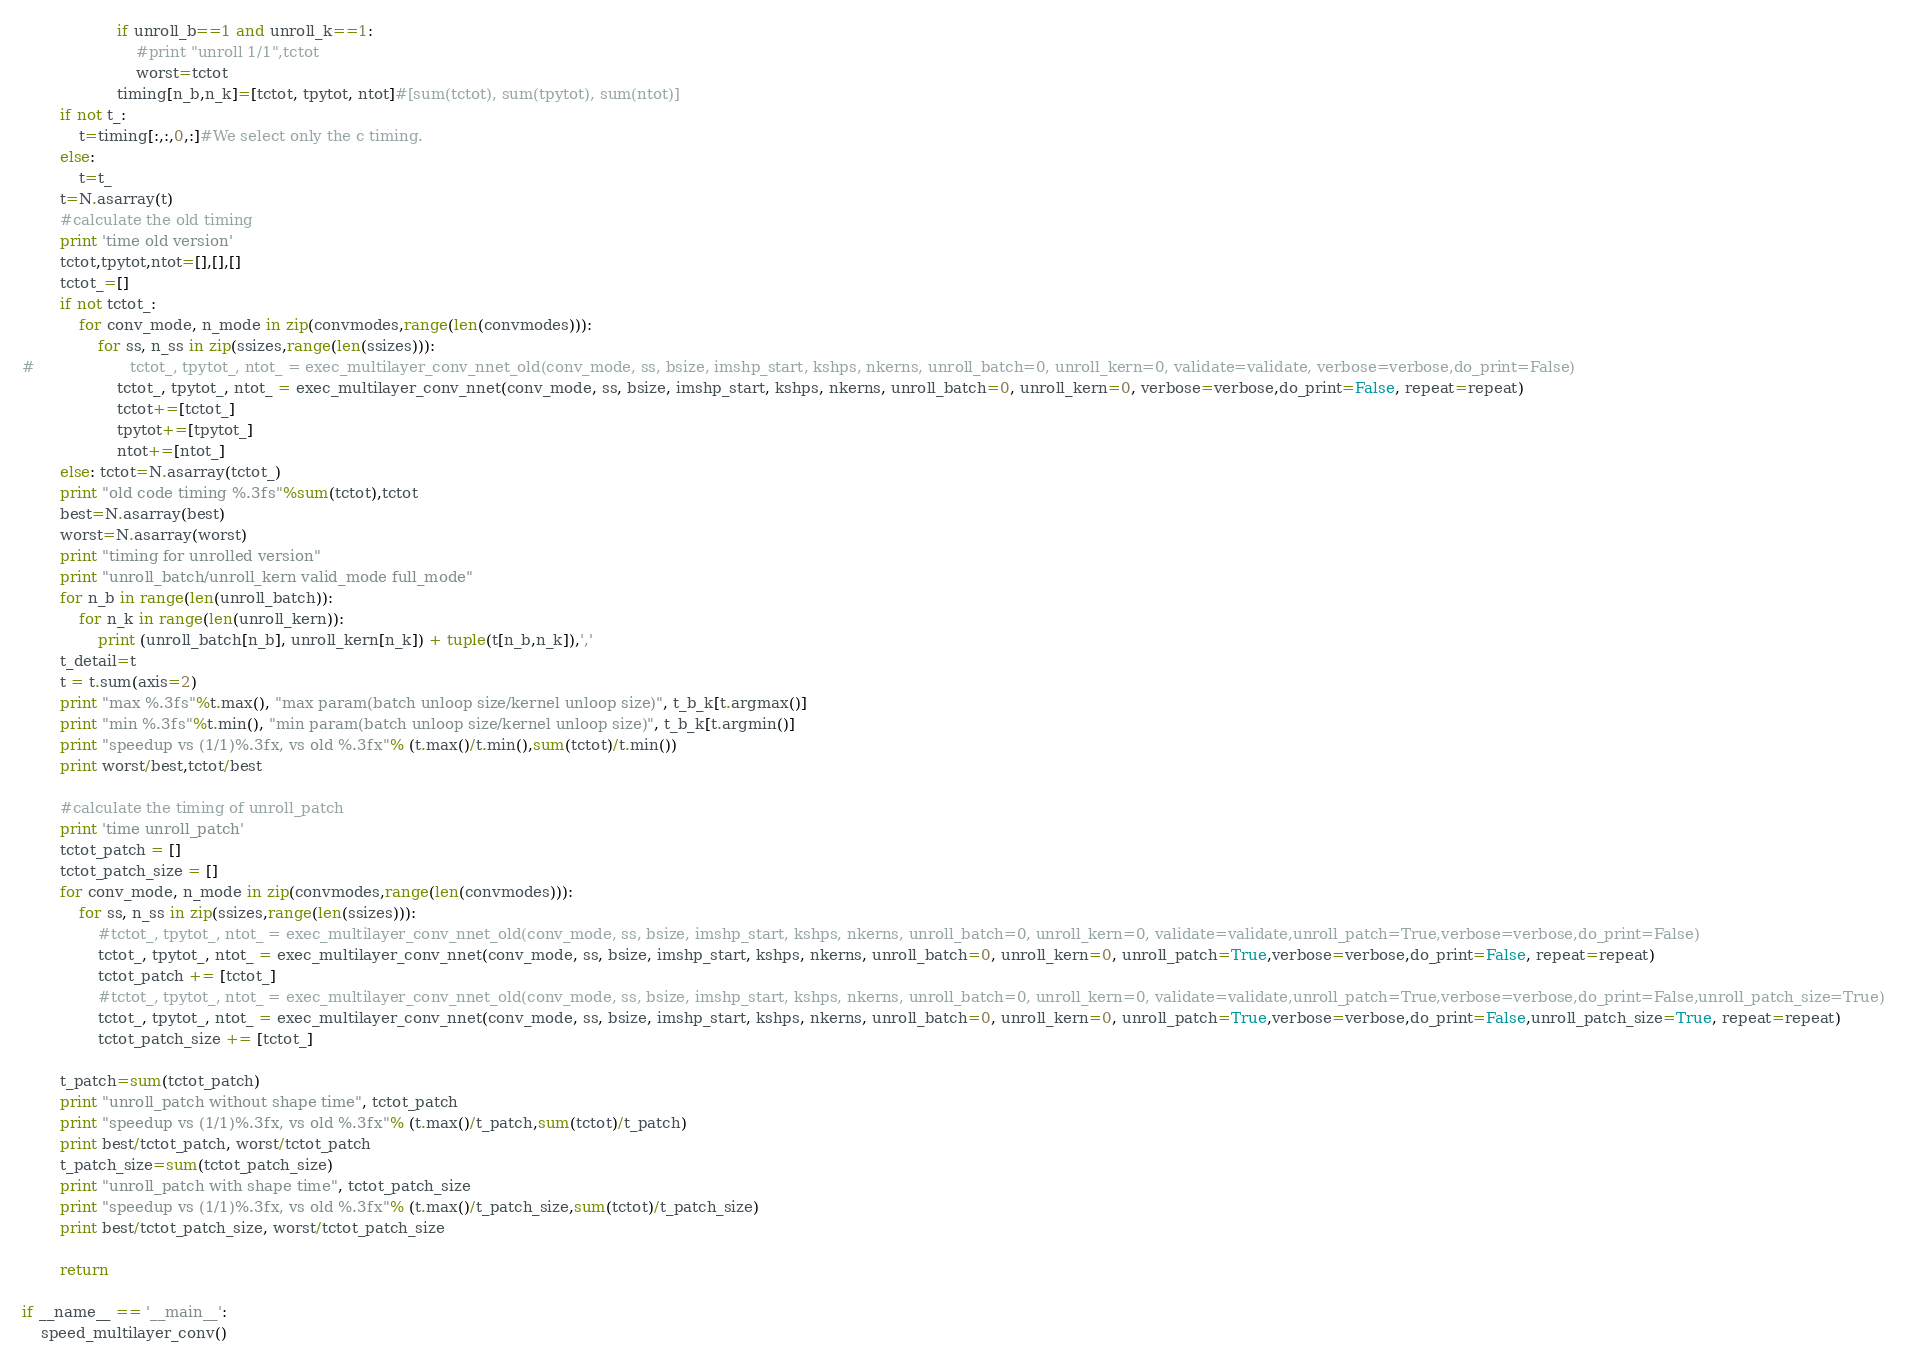Convert code to text. <code><loc_0><loc_0><loc_500><loc_500><_Python_>                    if unroll_b==1 and unroll_k==1:
                        #print "unroll 1/1",tctot
                        worst=tctot
                    timing[n_b,n_k]=[tctot, tpytot, ntot]#[sum(tctot), sum(tpytot), sum(ntot)]
        if not t_:
            t=timing[:,:,0,:]#We select only the c timing.
        else:
            t=t_
        t=N.asarray(t)
        #calculate the old timing
        print 'time old version'
        tctot,tpytot,ntot=[],[],[]
        tctot_=[]
        if not tctot_:
            for conv_mode, n_mode in zip(convmodes,range(len(convmodes))):
                for ss, n_ss in zip(ssizes,range(len(ssizes))):
#                    tctot_, tpytot_, ntot_ = exec_multilayer_conv_nnet_old(conv_mode, ss, bsize, imshp_start, kshps, nkerns, unroll_batch=0, unroll_kern=0, validate=validate, verbose=verbose,do_print=False)
                    tctot_, tpytot_, ntot_ = exec_multilayer_conv_nnet(conv_mode, ss, bsize, imshp_start, kshps, nkerns, unroll_batch=0, unroll_kern=0, verbose=verbose,do_print=False, repeat=repeat)
                    tctot+=[tctot_]
                    tpytot+=[tpytot_]
                    ntot+=[ntot_]
        else: tctot=N.asarray(tctot_)
        print "old code timing %.3fs"%sum(tctot),tctot
        best=N.asarray(best)
        worst=N.asarray(worst)
        print "timing for unrolled version"
        print "unroll_batch/unroll_kern valid_mode full_mode"
        for n_b in range(len(unroll_batch)):
            for n_k in range(len(unroll_kern)):
                print (unroll_batch[n_b], unroll_kern[n_k]) + tuple(t[n_b,n_k]),','
        t_detail=t
        t = t.sum(axis=2)
        print "max %.3fs"%t.max(), "max param(batch unloop size/kernel unloop size)", t_b_k[t.argmax()]
        print "min %.3fs"%t.min(), "min param(batch unloop size/kernel unloop size)", t_b_k[t.argmin()]
        print "speedup vs (1/1)%.3fx, vs old %.3fx"% (t.max()/t.min(),sum(tctot)/t.min())
        print worst/best,tctot/best

        #calculate the timing of unroll_patch
        print 'time unroll_patch'
        tctot_patch = []
        tctot_patch_size = []
        for conv_mode, n_mode in zip(convmodes,range(len(convmodes))):
            for ss, n_ss in zip(ssizes,range(len(ssizes))):
                #tctot_, tpytot_, ntot_ = exec_multilayer_conv_nnet_old(conv_mode, ss, bsize, imshp_start, kshps, nkerns, unroll_batch=0, unroll_kern=0, validate=validate,unroll_patch=True,verbose=verbose,do_print=False)
                tctot_, tpytot_, ntot_ = exec_multilayer_conv_nnet(conv_mode, ss, bsize, imshp_start, kshps, nkerns, unroll_batch=0, unroll_kern=0, unroll_patch=True,verbose=verbose,do_print=False, repeat=repeat)
                tctot_patch += [tctot_]
                #tctot_, tpytot_, ntot_ = exec_multilayer_conv_nnet_old(conv_mode, ss, bsize, imshp_start, kshps, nkerns, unroll_batch=0, unroll_kern=0, validate=validate,unroll_patch=True,verbose=verbose,do_print=False,unroll_patch_size=True)
                tctot_, tpytot_, ntot_ = exec_multilayer_conv_nnet(conv_mode, ss, bsize, imshp_start, kshps, nkerns, unroll_batch=0, unroll_kern=0, unroll_patch=True,verbose=verbose,do_print=False,unroll_patch_size=True, repeat=repeat)
                tctot_patch_size += [tctot_]

        t_patch=sum(tctot_patch)
        print "unroll_patch without shape time", tctot_patch
        print "speedup vs (1/1)%.3fx, vs old %.3fx"% (t.max()/t_patch,sum(tctot)/t_patch)
        print best/tctot_patch, worst/tctot_patch
        t_patch_size=sum(tctot_patch_size)
        print "unroll_patch with shape time", tctot_patch_size
        print "speedup vs (1/1)%.3fx, vs old %.3fx"% (t.max()/t_patch_size,sum(tctot)/t_patch_size)
        print best/tctot_patch_size, worst/tctot_patch_size
        
        return

if __name__ == '__main__':
    speed_multilayer_conv()
</code> 